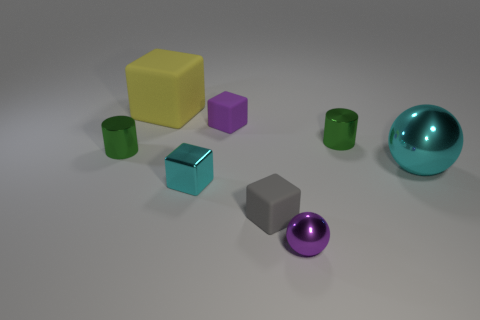Is the large shiny ball the same color as the tiny metallic block?
Give a very brief answer. Yes. Is there any other thing of the same color as the big sphere?
Your answer should be very brief. Yes. Do the large metallic object and the metallic cube that is behind the small purple metal ball have the same color?
Your response must be concise. Yes. Is the color of the large object that is right of the big matte thing the same as the metallic cube?
Keep it short and to the point. Yes. There is a big thing that is the same color as the small metallic cube; what material is it?
Keep it short and to the point. Metal. Is there a tiny matte thing that has the same color as the small sphere?
Give a very brief answer. Yes. There is a gray thing that is the same material as the large cube; what shape is it?
Offer a terse response. Cube. There is a metallic cylinder on the left side of the tiny purple sphere to the right of the tiny purple cube; what is its size?
Make the answer very short. Small. What number of small things are yellow metallic spheres or gray cubes?
Your response must be concise. 1. How many other objects are there of the same color as the tiny metal block?
Provide a succinct answer. 1. 